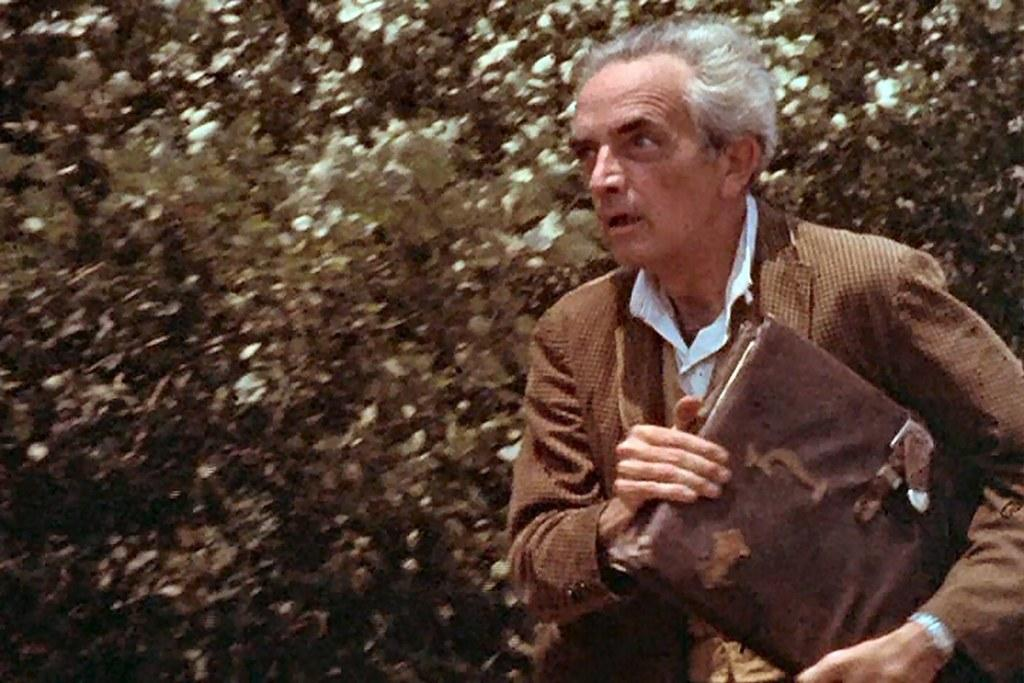Who or what is present in the image? There is a person in the image. What is the person holding in the image? The person is holding a file. What type of natural environment can be seen in the image? There are trees in the image. Can you see a kitten playing on the edge of the flight in the image? There is no kitten or flight present in the image. 